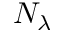Convert formula to latex. <formula><loc_0><loc_0><loc_500><loc_500>N _ { \lambda }</formula> 